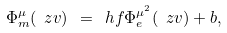<formula> <loc_0><loc_0><loc_500><loc_500>\Phi _ { m } ^ { \mu } ( \ z v ) \ = \ h f \Phi _ { e } ^ { \mu ^ { 2 } } ( \ z v ) + b ,</formula> 